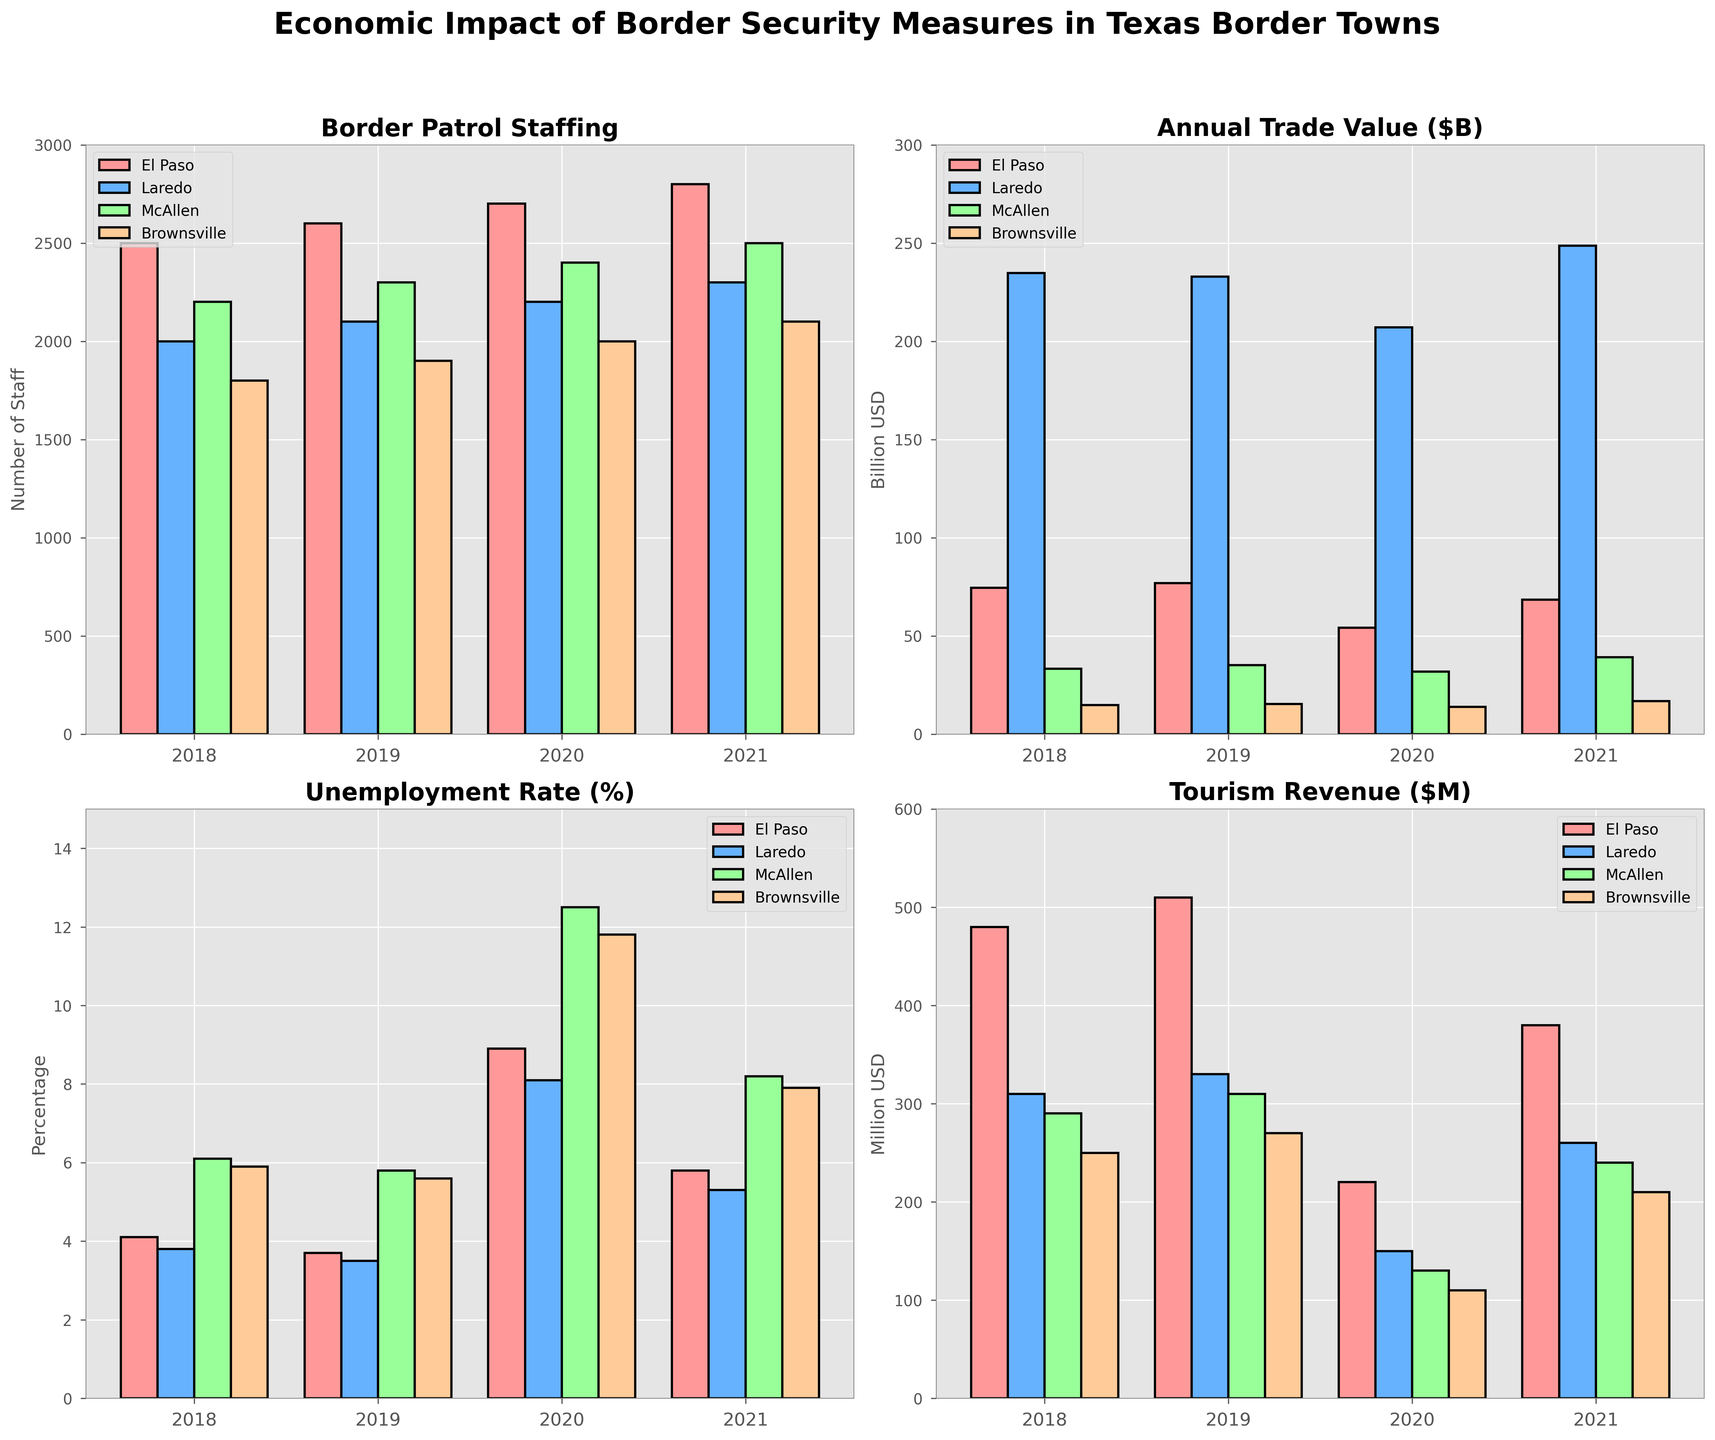What's the trend in Border Patrol Staffing from 2018 to 2021 in El Paso? From the bar chart depicting 'Border Patrol Staffing', visually track the height of the bars for El Paso across all years. In 2018, the bar is at 2500, in 2019 it is higher at 2600, in 2020 it increases to 2700, and in 2021 it reaches the highest at 2800. Hence, the trend shows a continuous increase each year.
Answer: Increasing Which city had the highest Annual Trade Value in 2021? Observe the bar heights in the 'Annual Trade Value' subplot for the year 2021. Laredo has the tallest bar among the four cities in 2021, significantly higher than the others.
Answer: Laredo What is the difference in Unemployment Rate between El Paso and McAllen for 2020? Locate the 'Unemployment Rate' subplot, and for the year 2020, note the heights of the bars for El Paso and McAllen. The height for El Paso is 8.9% and for McAllen is 12.5%. Subtracting these values gives 12.5% - 8.9% = 3.6%.
Answer: 3.6% How did Tourism Revenue in Brownsville change from 2019 to 2020? Check the 'Tourism Revenue' subplot, focus on the bars representing Brownsville for the years 2019 and 2020. In 2019, the bar is at 270 million USD, while in 2020, it drops to 110 million USD. This shows a decline.
Answer: Decreased Compare the Unemployment Rate in Laredo and McAllen in 2021. Which was higher and by how much? Refer to the 'Unemployment Rate' subplot for 2021. The heights of the bars for Laredo and McAllen indicate 5.3% and 8.2%, respectively. McAllen's rate was higher by 8.2% - 5.3% = 2.9%.
Answer: McAllen by 2.9% What was the largest value of Annual Trade in any city across all years? In the 'Annual Trade Value' subplot, identify the tallest bar across all years and cities. Laredo in 2018 has the highest value at 234.7 billion USD.
Answer: 234.7 billion USD How did El Paso's Annual Trade Value change from 2020 to 2021? In the 'Annual Trade Value' subplot, compare the heights of El Paso's bars for 2020 and 2021. In 2020, the value is at 54.2 billion USD, and in 2021, it increases to 68.5 billion USD, indicating an increase.
Answer: Increased Which city had the lowest Tourism Revenue in 2020? Look at the 'Tourism Revenue' subplot and focus on the bars for 2020. The shortest bar is for McAllen, indicating the lowest revenue at 130 million USD.
Answer: McAllen Which measure had the most significant drop in McAllen in 2020 compared to 2019? Examine all subplots and compare McAllen's bar heights for 2019 and 2020 across all measures. 'Tourism Revenue' shows a drop from 310 million USD to 130 million USD, which is the most significant in percentage terms.
Answer: Tourism Revenue What's the average Annual Trade Value for Brownsville from 2018 to 2021? Sum Brownsville's Annual Trade Values across the four years: 14.8 + 15.3 + 13.9 + 16.7 = 60.7 billion USD, then divide by 4. The average is 60.7 / 4 = 15.175 billion USD.
Answer: 15.175 billion USD 